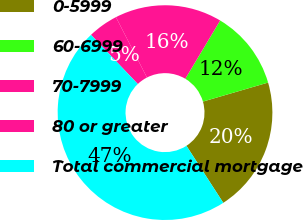Convert chart to OTSL. <chart><loc_0><loc_0><loc_500><loc_500><pie_chart><fcel>0-5999<fcel>60-6999<fcel>70-7999<fcel>80 or greater<fcel>Total commercial mortgage<nl><fcel>20.39%<fcel>11.9%<fcel>16.14%<fcel>4.55%<fcel>47.02%<nl></chart> 